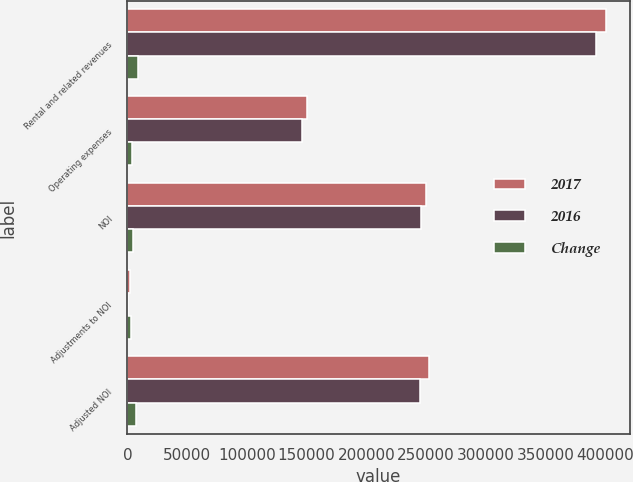Convert chart. <chart><loc_0><loc_0><loc_500><loc_500><stacked_bar_chart><ecel><fcel>Rental and related revenues<fcel>Operating expenses<fcel>NOI<fcel>Adjustments to NOI<fcel>Adjusted NOI<nl><fcel>2017<fcel>400747<fcel>150329<fcel>250418<fcel>2183<fcel>252601<nl><fcel>2016<fcel>392166<fcel>146300<fcel>245866<fcel>523<fcel>245343<nl><fcel>Change<fcel>8581<fcel>4029<fcel>4552<fcel>2706<fcel>7258<nl></chart> 